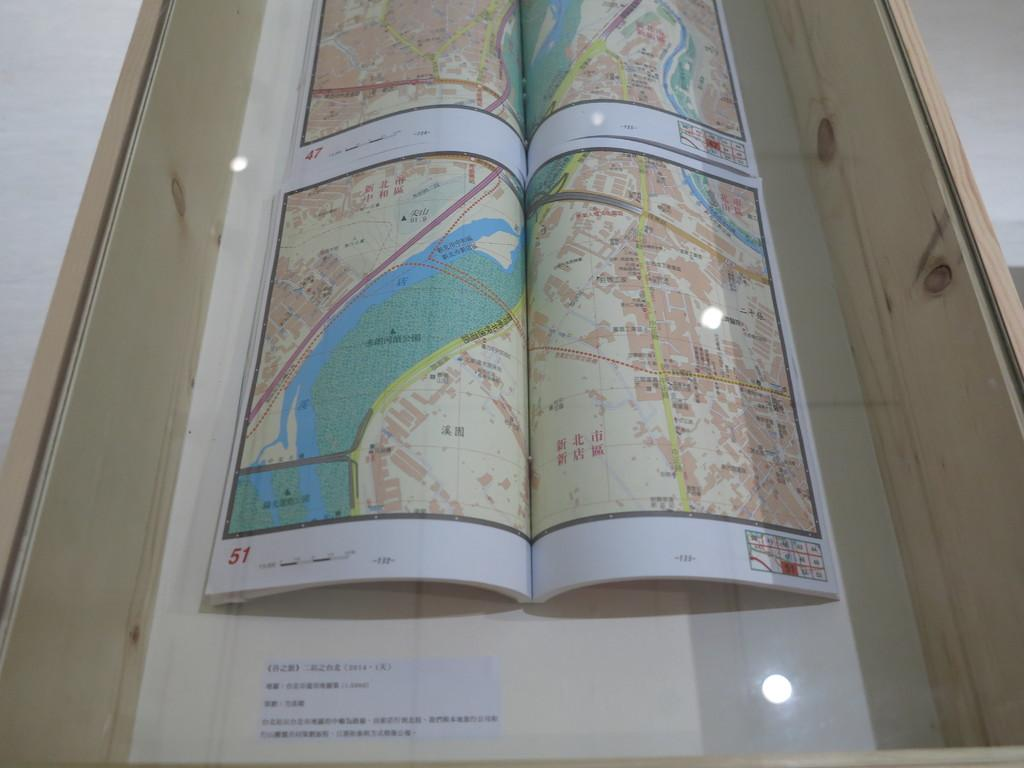What type of container is in the image? There is a wooden box in the image. What material covers the top of the wooden box? The wooden box has glass on the top. What can be seen through the glass on the wooden box? Maps are visible through the glass. Is there any text present in the image? Yes, there is text at the bottom of the picture. How many rabbits are hopping around the wooden box in the image? There are no rabbits present in the image. What type of ball is being used to play with the wooden box in the image? There is no ball or any indication of a game being played in the image. 